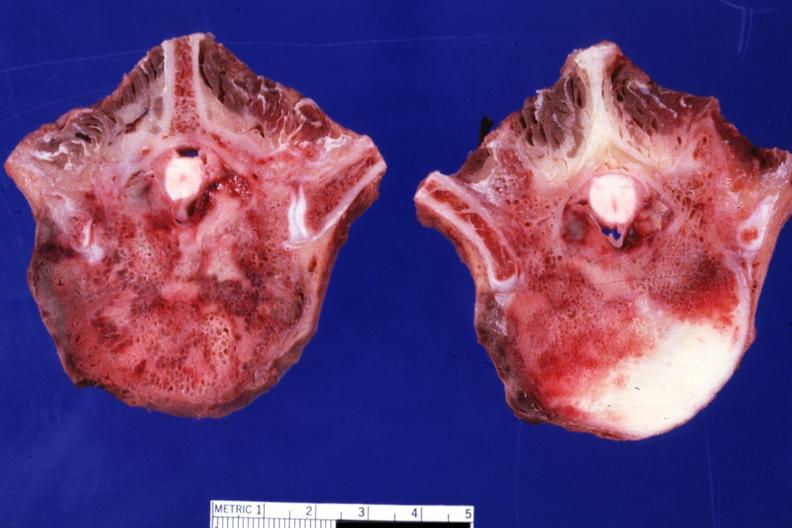what does this image show?
Answer the question using a single word or phrase. Excellent close-up of two vertebral bodies with obvious tumor teratocarcinoma primary in mediastinum 